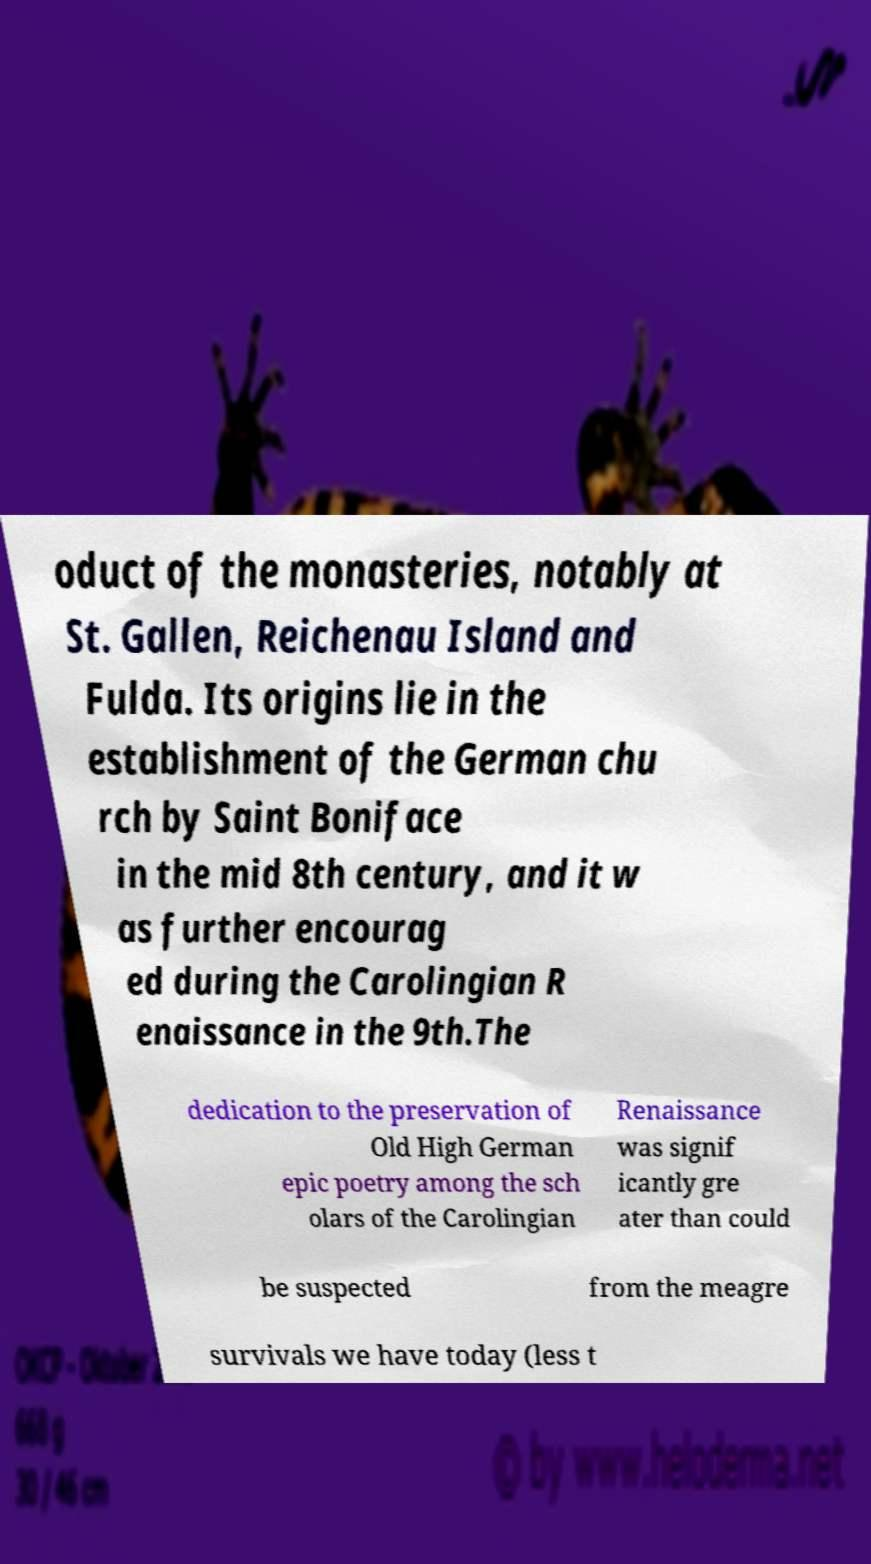Could you extract and type out the text from this image? oduct of the monasteries, notably at St. Gallen, Reichenau Island and Fulda. Its origins lie in the establishment of the German chu rch by Saint Boniface in the mid 8th century, and it w as further encourag ed during the Carolingian R enaissance in the 9th.The dedication to the preservation of Old High German epic poetry among the sch olars of the Carolingian Renaissance was signif icantly gre ater than could be suspected from the meagre survivals we have today (less t 